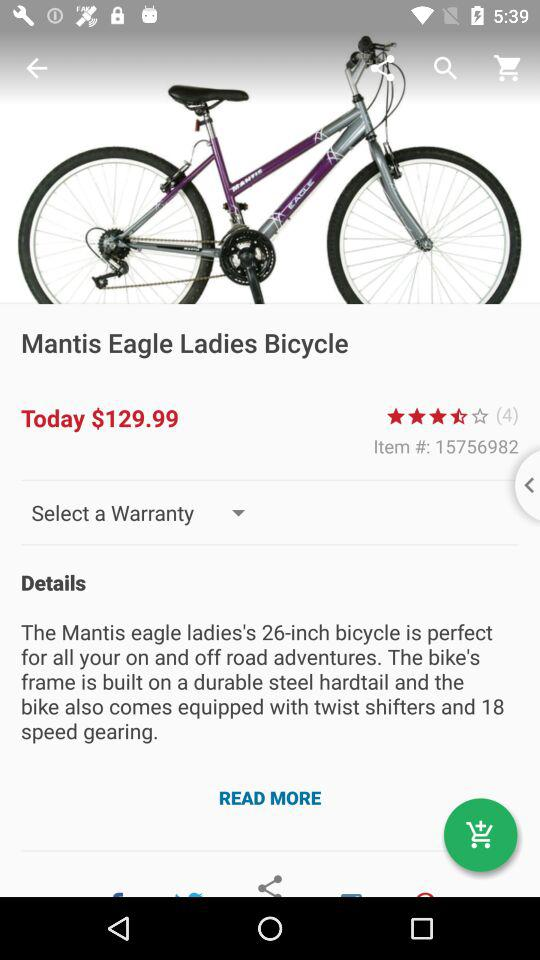What is the price of this product?
Answer the question using a single word or phrase. $129.99 